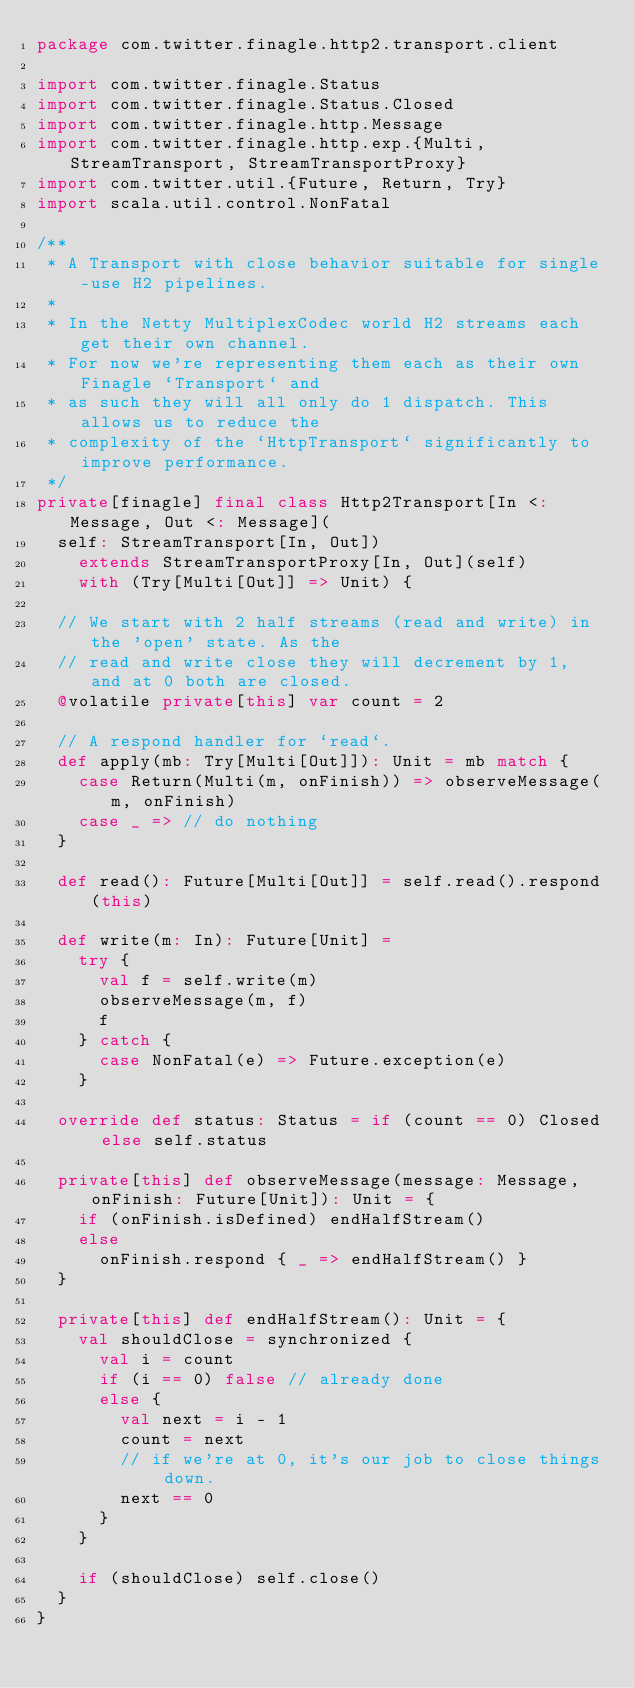<code> <loc_0><loc_0><loc_500><loc_500><_Scala_>package com.twitter.finagle.http2.transport.client

import com.twitter.finagle.Status
import com.twitter.finagle.Status.Closed
import com.twitter.finagle.http.Message
import com.twitter.finagle.http.exp.{Multi, StreamTransport, StreamTransportProxy}
import com.twitter.util.{Future, Return, Try}
import scala.util.control.NonFatal

/**
 * A Transport with close behavior suitable for single-use H2 pipelines.
 *
 * In the Netty MultiplexCodec world H2 streams each get their own channel.
 * For now we're representing them each as their own Finagle `Transport` and
 * as such they will all only do 1 dispatch. This allows us to reduce the
 * complexity of the `HttpTransport` significantly to improve performance.
 */
private[finagle] final class Http2Transport[In <: Message, Out <: Message](
  self: StreamTransport[In, Out])
    extends StreamTransportProxy[In, Out](self)
    with (Try[Multi[Out]] => Unit) {

  // We start with 2 half streams (read and write) in the 'open' state. As the
  // read and write close they will decrement by 1, and at 0 both are closed.
  @volatile private[this] var count = 2

  // A respond handler for `read`.
  def apply(mb: Try[Multi[Out]]): Unit = mb match {
    case Return(Multi(m, onFinish)) => observeMessage(m, onFinish)
    case _ => // do nothing
  }

  def read(): Future[Multi[Out]] = self.read().respond(this)

  def write(m: In): Future[Unit] =
    try {
      val f = self.write(m)
      observeMessage(m, f)
      f
    } catch {
      case NonFatal(e) => Future.exception(e)
    }

  override def status: Status = if (count == 0) Closed else self.status

  private[this] def observeMessage(message: Message, onFinish: Future[Unit]): Unit = {
    if (onFinish.isDefined) endHalfStream()
    else
      onFinish.respond { _ => endHalfStream() }
  }

  private[this] def endHalfStream(): Unit = {
    val shouldClose = synchronized {
      val i = count
      if (i == 0) false // already done
      else {
        val next = i - 1
        count = next
        // if we're at 0, it's our job to close things down.
        next == 0
      }
    }

    if (shouldClose) self.close()
  }
}
</code> 